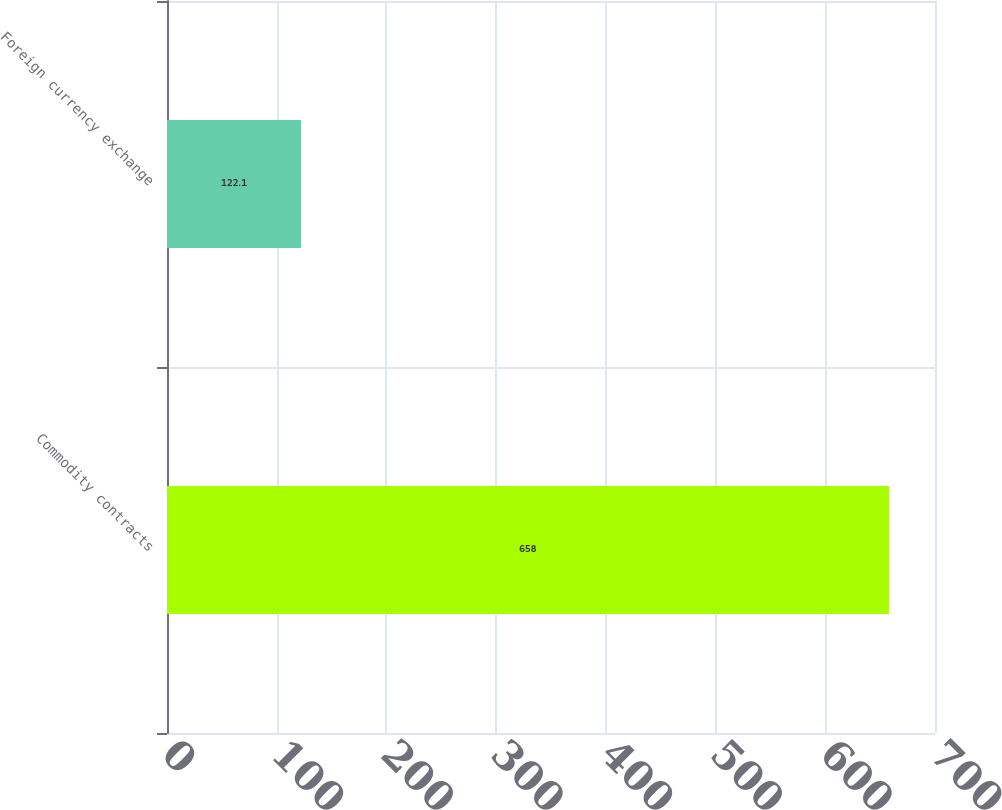<chart> <loc_0><loc_0><loc_500><loc_500><bar_chart><fcel>Commodity contracts<fcel>Foreign currency exchange<nl><fcel>658<fcel>122.1<nl></chart> 